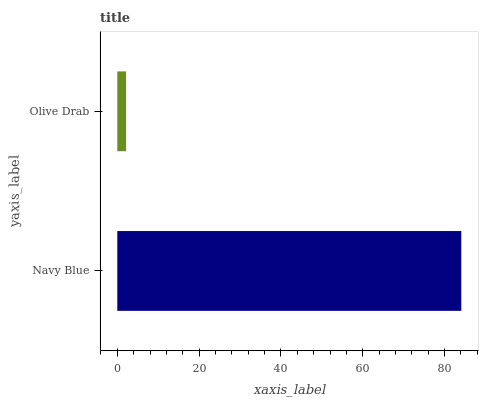Is Olive Drab the minimum?
Answer yes or no. Yes. Is Navy Blue the maximum?
Answer yes or no. Yes. Is Olive Drab the maximum?
Answer yes or no. No. Is Navy Blue greater than Olive Drab?
Answer yes or no. Yes. Is Olive Drab less than Navy Blue?
Answer yes or no. Yes. Is Olive Drab greater than Navy Blue?
Answer yes or no. No. Is Navy Blue less than Olive Drab?
Answer yes or no. No. Is Navy Blue the high median?
Answer yes or no. Yes. Is Olive Drab the low median?
Answer yes or no. Yes. Is Olive Drab the high median?
Answer yes or no. No. Is Navy Blue the low median?
Answer yes or no. No. 